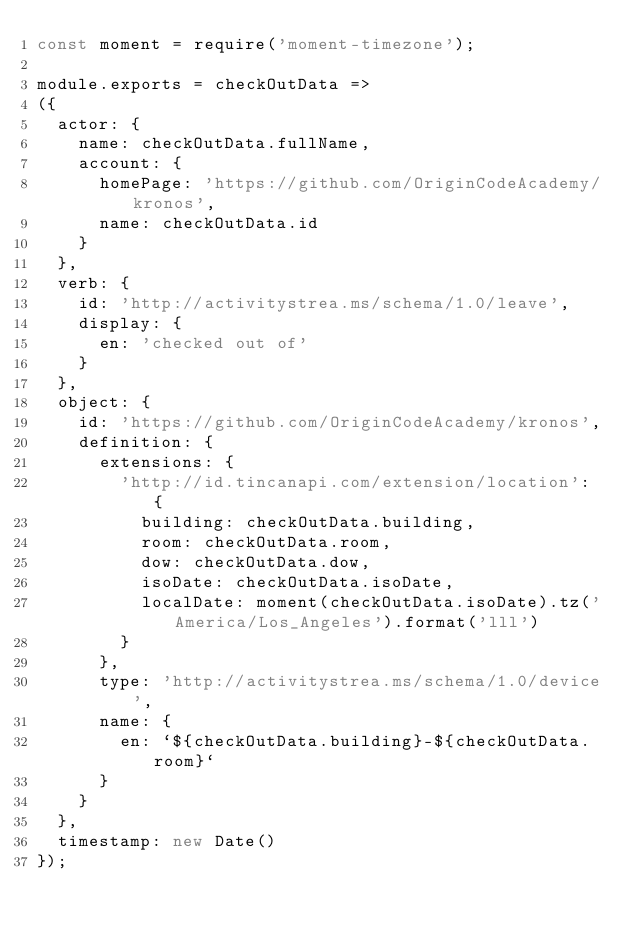Convert code to text. <code><loc_0><loc_0><loc_500><loc_500><_JavaScript_>const moment = require('moment-timezone');

module.exports = checkOutData =>
({
  actor: {
    name: checkOutData.fullName,
    account: {
      homePage: 'https://github.com/OriginCodeAcademy/kronos',
      name: checkOutData.id
    }
  },
  verb: {
    id: 'http://activitystrea.ms/schema/1.0/leave',
    display: {
      en: 'checked out of'
    }
  },
  object: {
    id: 'https://github.com/OriginCodeAcademy/kronos',
    definition: {
      extensions: {
        'http://id.tincanapi.com/extension/location': {
          building: checkOutData.building,
          room: checkOutData.room,
          dow: checkOutData.dow,
          isoDate: checkOutData.isoDate,
          localDate: moment(checkOutData.isoDate).tz('America/Los_Angeles').format('lll')
        }
      },
      type: 'http://activitystrea.ms/schema/1.0/device',
      name: {
        en: `${checkOutData.building}-${checkOutData.room}`
      }
    }
  },
  timestamp: new Date()
});
</code> 